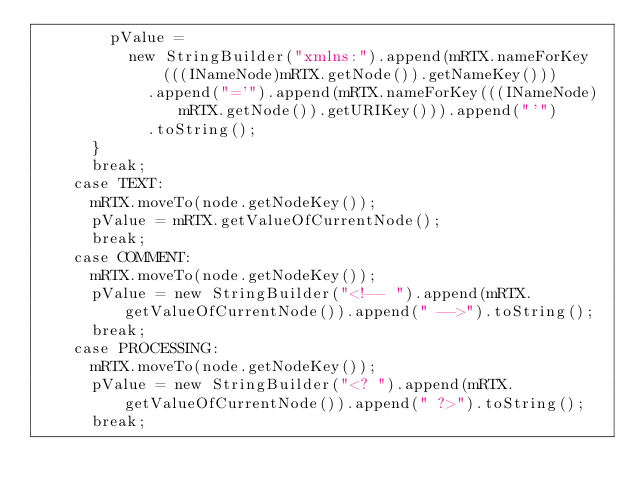<code> <loc_0><loc_0><loc_500><loc_500><_Java_>        pValue =
          new StringBuilder("xmlns:").append(mRTX.nameForKey(((INameNode)mRTX.getNode()).getNameKey()))
            .append("='").append(mRTX.nameForKey(((INameNode)mRTX.getNode()).getURIKey())).append("'")
            .toString();
      }
      break;
    case TEXT:
      mRTX.moveTo(node.getNodeKey());
      pValue = mRTX.getValueOfCurrentNode();
      break;
    case COMMENT:
      mRTX.moveTo(node.getNodeKey());
      pValue = new StringBuilder("<!-- ").append(mRTX.getValueOfCurrentNode()).append(" -->").toString();
      break;
    case PROCESSING:
      mRTX.moveTo(node.getNodeKey());
      pValue = new StringBuilder("<? ").append(mRTX.getValueOfCurrentNode()).append(" ?>").toString();
      break;</code> 